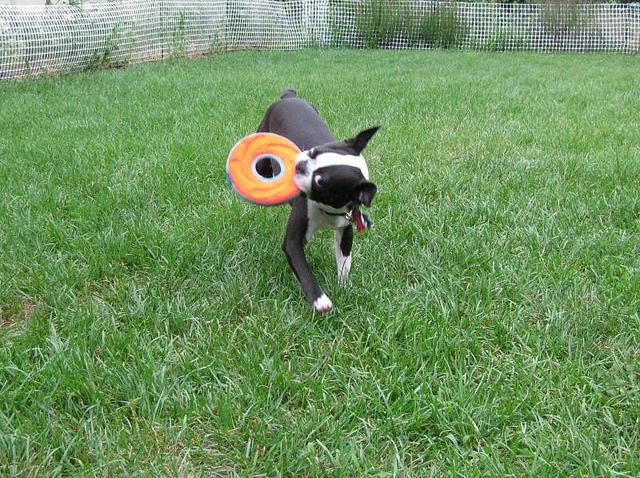Is the dog playing with someone?
Answer briefly. No. How does the dog carry his Frisbee?
Answer briefly. In his mouth. What type of dog is shown?
Quick response, please. Bulldog. 